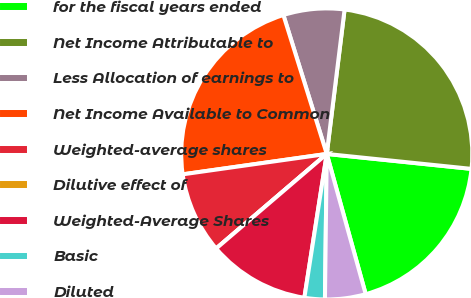Convert chart to OTSL. <chart><loc_0><loc_0><loc_500><loc_500><pie_chart><fcel>for the fiscal years ended<fcel>Net Income Attributable to<fcel>Less Allocation of earnings to<fcel>Net Income Available to Common<fcel>Weighted-average shares<fcel>Dilutive effect of<fcel>Weighted-Average Shares<fcel>Basic<fcel>Diluted<nl><fcel>19.05%<fcel>24.68%<fcel>6.77%<fcel>22.42%<fcel>9.02%<fcel>0.0%<fcel>11.28%<fcel>2.26%<fcel>4.51%<nl></chart> 